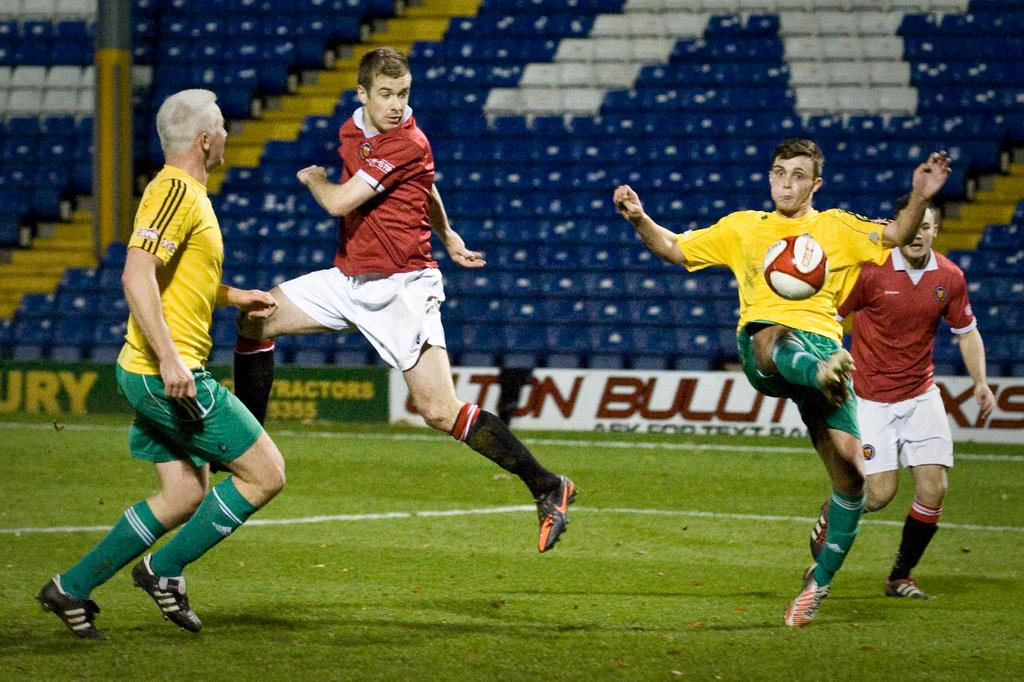Provide a one-sentence caption for the provided image. Soccer athetes on a field that is sponsored by some tractor company. 